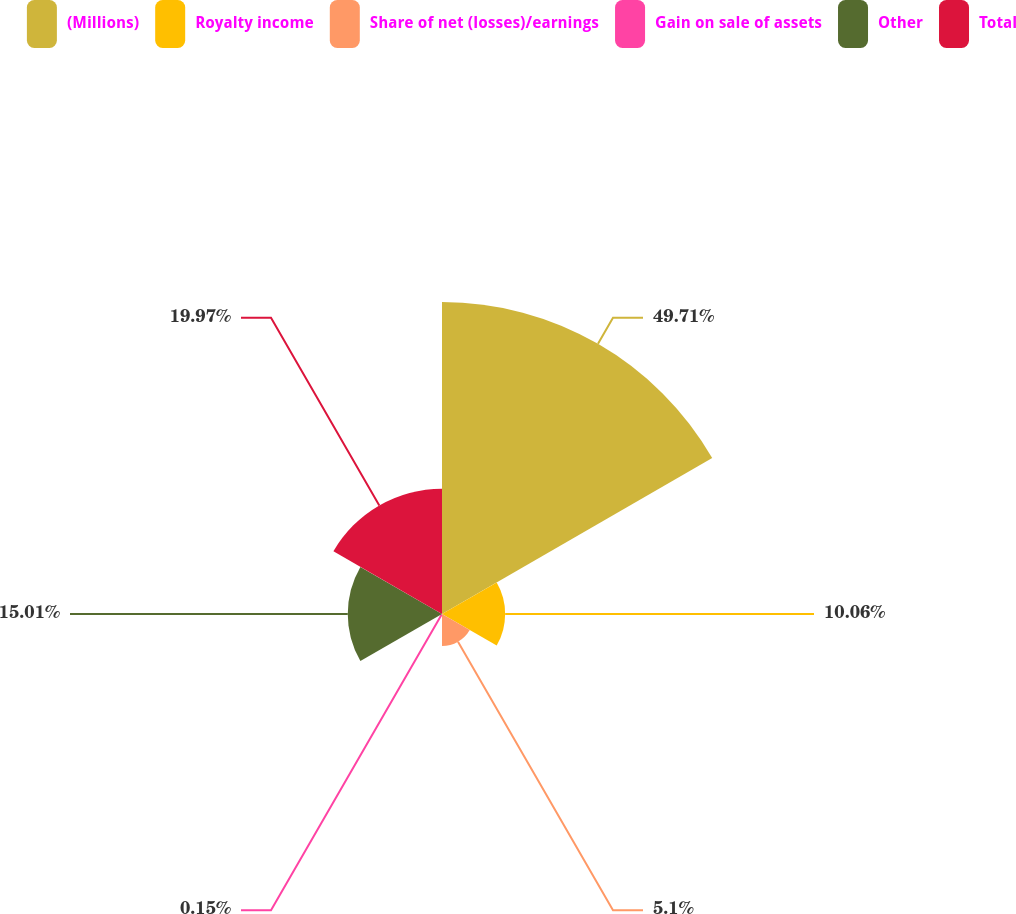Convert chart to OTSL. <chart><loc_0><loc_0><loc_500><loc_500><pie_chart><fcel>(Millions)<fcel>Royalty income<fcel>Share of net (losses)/earnings<fcel>Gain on sale of assets<fcel>Other<fcel>Total<nl><fcel>49.7%<fcel>10.06%<fcel>5.1%<fcel>0.15%<fcel>15.01%<fcel>19.97%<nl></chart> 